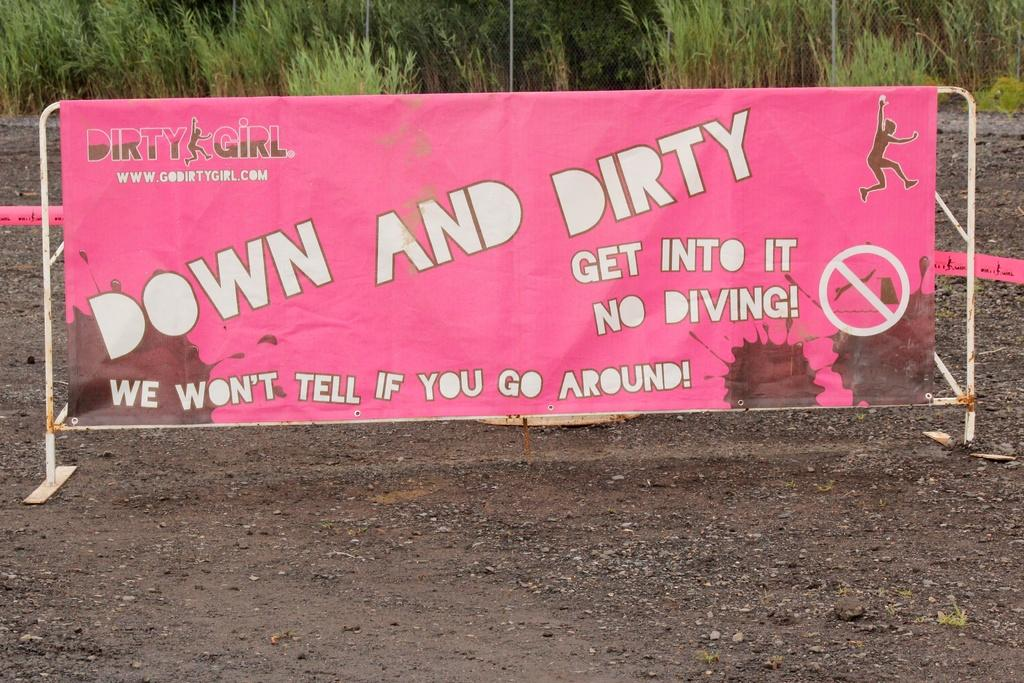What color is the poster in the image? The poster in the image is pink. Where is the poster located in the image? The poster is in the center of the image. What can be seen at the top side of the image? There are plants at the top side of the image. Who is the owner of the flag in the image? There is no flag present in the image. How many wheels can be seen on the poster in the image? The poster in the image does not have any wheels. 